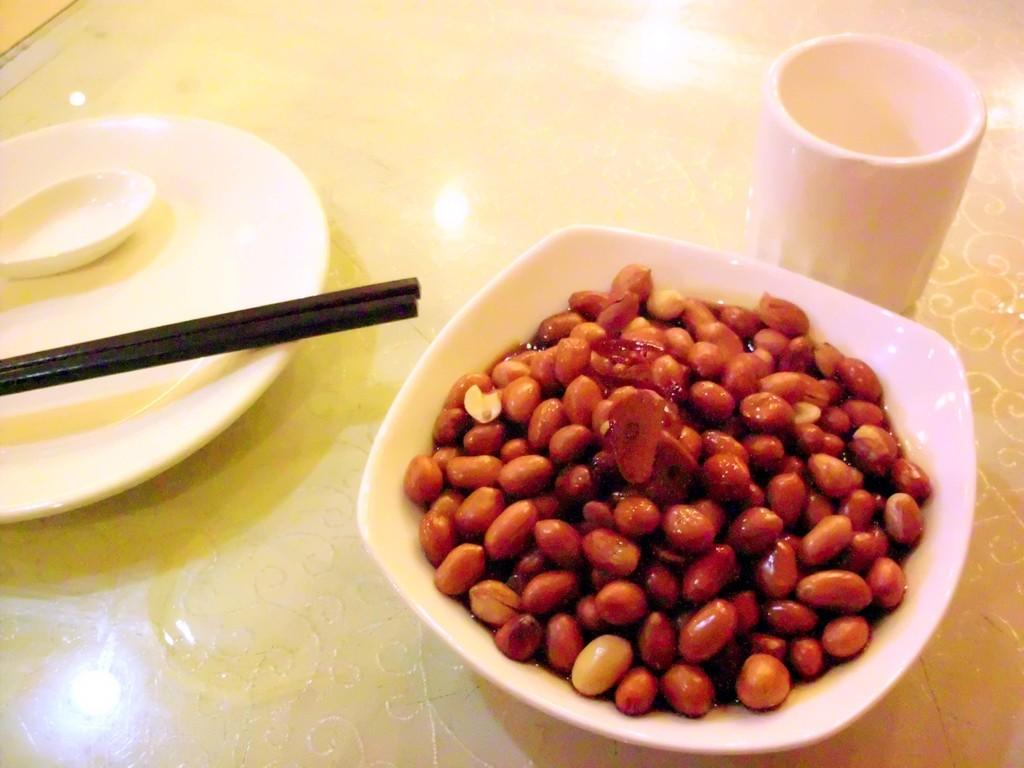What type of container is present in the image? There is a glass in the image. What other type of container can be seen in the image? There is a plate in the image. What utensils are visible in the image? There are spoon sticks in the image. What is in the bowl that is visible in the image? There is a bowl with food in the image. What type of chain can be seen hanging from the glass in the image? There is no chain hanging from the glass in the image. 